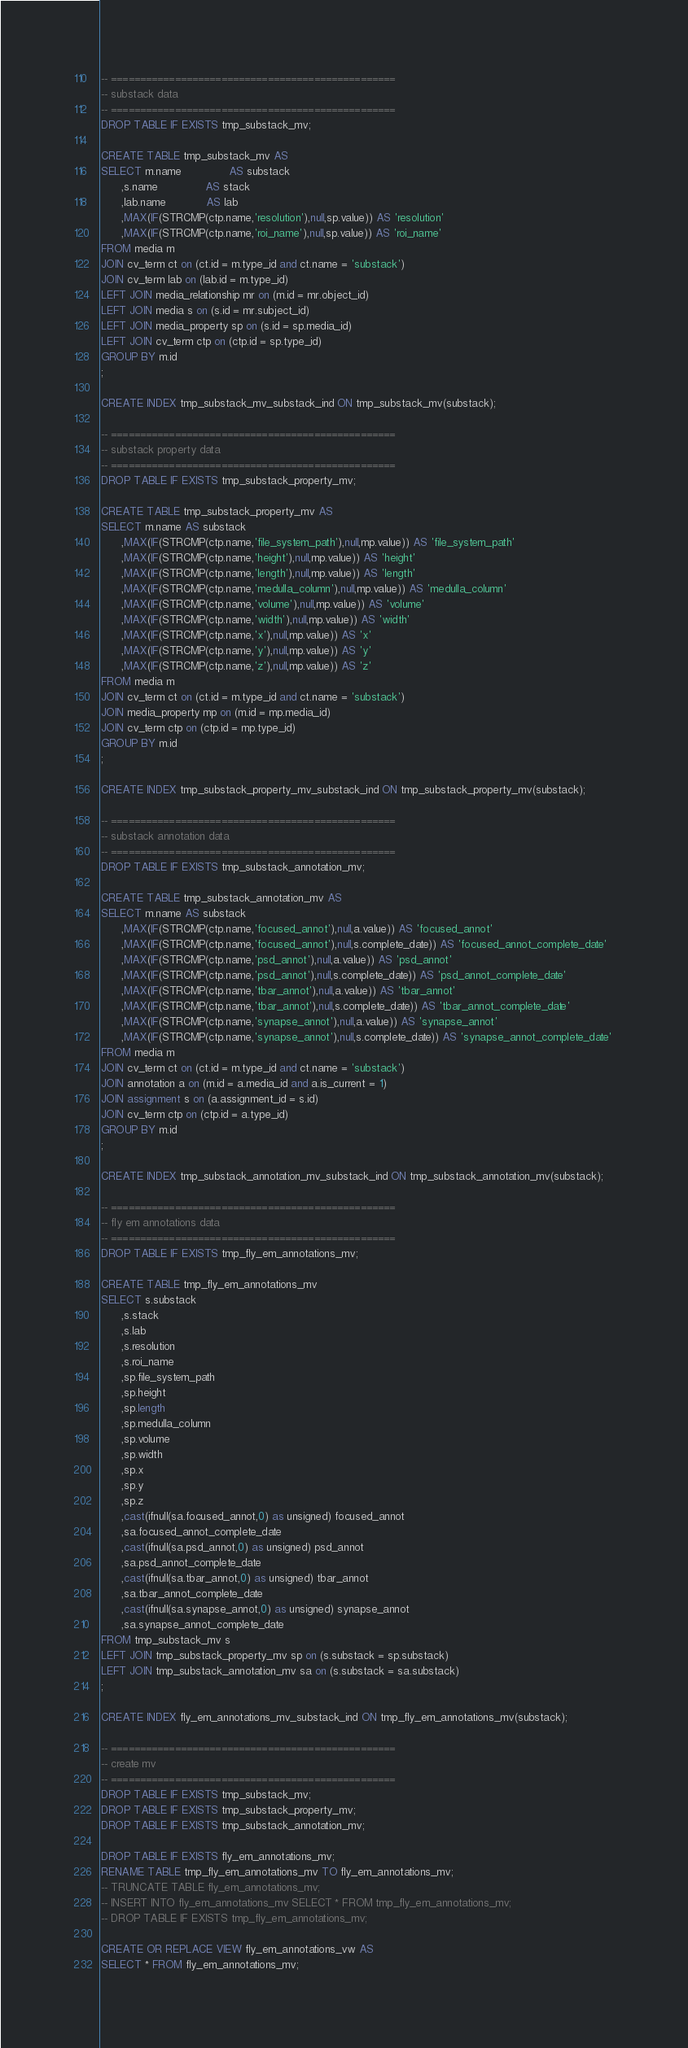Convert code to text. <code><loc_0><loc_0><loc_500><loc_500><_SQL_>-- =================================================
-- substack data
-- =================================================
DROP TABLE IF EXISTS tmp_substack_mv;

CREATE TABLE tmp_substack_mv AS
SELECT m.name              AS substack
      ,s.name              AS stack
      ,lab.name            AS lab
      ,MAX(IF(STRCMP(ctp.name,'resolution'),null,sp.value)) AS 'resolution'
      ,MAX(IF(STRCMP(ctp.name,'roi_name'),null,sp.value)) AS 'roi_name'
FROM media m
JOIN cv_term ct on (ct.id = m.type_id and ct.name = 'substack')
JOIN cv_term lab on (lab.id = m.type_id)
LEFT JOIN media_relationship mr on (m.id = mr.object_id)
LEFT JOIN media s on (s.id = mr.subject_id)
LEFT JOIN media_property sp on (s.id = sp.media_id)
LEFT JOIN cv_term ctp on (ctp.id = sp.type_id)
GROUP BY m.id
;

CREATE INDEX tmp_substack_mv_substack_ind ON tmp_substack_mv(substack);

-- =================================================
-- substack property data
-- =================================================
DROP TABLE IF EXISTS tmp_substack_property_mv;

CREATE TABLE tmp_substack_property_mv AS
SELECT m.name AS substack
      ,MAX(IF(STRCMP(ctp.name,'file_system_path'),null,mp.value)) AS 'file_system_path'
      ,MAX(IF(STRCMP(ctp.name,'height'),null,mp.value)) AS 'height'
      ,MAX(IF(STRCMP(ctp.name,'length'),null,mp.value)) AS 'length'
      ,MAX(IF(STRCMP(ctp.name,'medulla_column'),null,mp.value)) AS 'medulla_column'
      ,MAX(IF(STRCMP(ctp.name,'volume'),null,mp.value)) AS 'volume'
      ,MAX(IF(STRCMP(ctp.name,'width'),null,mp.value)) AS 'width'
      ,MAX(IF(STRCMP(ctp.name,'x'),null,mp.value)) AS 'x'
      ,MAX(IF(STRCMP(ctp.name,'y'),null,mp.value)) AS 'y'
      ,MAX(IF(STRCMP(ctp.name,'z'),null,mp.value)) AS 'z'
FROM media m
JOIN cv_term ct on (ct.id = m.type_id and ct.name = 'substack')
JOIN media_property mp on (m.id = mp.media_id)
JOIN cv_term ctp on (ctp.id = mp.type_id)
GROUP BY m.id
;

CREATE INDEX tmp_substack_property_mv_substack_ind ON tmp_substack_property_mv(substack);

-- =================================================
-- substack annotation data
-- =================================================
DROP TABLE IF EXISTS tmp_substack_annotation_mv;

CREATE TABLE tmp_substack_annotation_mv AS
SELECT m.name AS substack
      ,MAX(IF(STRCMP(ctp.name,'focused_annot'),null,a.value)) AS 'focused_annot'
      ,MAX(IF(STRCMP(ctp.name,'focused_annot'),null,s.complete_date)) AS 'focused_annot_complete_date' 
      ,MAX(IF(STRCMP(ctp.name,'psd_annot'),null,a.value)) AS 'psd_annot'
      ,MAX(IF(STRCMP(ctp.name,'psd_annot'),null,s.complete_date)) AS 'psd_annot_complete_date' 
      ,MAX(IF(STRCMP(ctp.name,'tbar_annot'),null,a.value)) AS 'tbar_annot'
      ,MAX(IF(STRCMP(ctp.name,'tbar_annot'),null,s.complete_date)) AS 'tbar_annot_complete_date' 
      ,MAX(IF(STRCMP(ctp.name,'synapse_annot'),null,a.value)) AS 'synapse_annot'
      ,MAX(IF(STRCMP(ctp.name,'synapse_annot'),null,s.complete_date)) AS 'synapse_annot_complete_date' 
FROM media m
JOIN cv_term ct on (ct.id = m.type_id and ct.name = 'substack')
JOIN annotation a on (m.id = a.media_id and a.is_current = 1)
JOIN assignment s on (a.assignment_id = s.id)
JOIN cv_term ctp on (ctp.id = a.type_id)
GROUP BY m.id
;

CREATE INDEX tmp_substack_annotation_mv_substack_ind ON tmp_substack_annotation_mv(substack);

-- =================================================
-- fly em annotations data
-- =================================================
DROP TABLE IF EXISTS tmp_fly_em_annotations_mv;

CREATE TABLE tmp_fly_em_annotations_mv
SELECT s.substack
      ,s.stack
      ,s.lab
      ,s.resolution
      ,s.roi_name
      ,sp.file_system_path
      ,sp.height
      ,sp.length
      ,sp.medulla_column
      ,sp.volume
      ,sp.width
      ,sp.x
      ,sp.y
      ,sp.z
      ,cast(ifnull(sa.focused_annot,0) as unsigned) focused_annot
      ,sa.focused_annot_complete_date
      ,cast(ifnull(sa.psd_annot,0) as unsigned) psd_annot
      ,sa.psd_annot_complete_date
      ,cast(ifnull(sa.tbar_annot,0) as unsigned) tbar_annot
      ,sa.tbar_annot_complete_date
      ,cast(ifnull(sa.synapse_annot,0) as unsigned) synapse_annot
      ,sa.synapse_annot_complete_date
FROM tmp_substack_mv s
LEFT JOIN tmp_substack_property_mv sp on (s.substack = sp.substack)
LEFT JOIN tmp_substack_annotation_mv sa on (s.substack = sa.substack)
;

CREATE INDEX fly_em_annotations_mv_substack_ind ON tmp_fly_em_annotations_mv(substack);

-- =================================================
-- create mv
-- =================================================
DROP TABLE IF EXISTS tmp_substack_mv;
DROP TABLE IF EXISTS tmp_substack_property_mv;
DROP TABLE IF EXISTS tmp_substack_annotation_mv;

DROP TABLE IF EXISTS fly_em_annotations_mv;
RENAME TABLE tmp_fly_em_annotations_mv TO fly_em_annotations_mv;
-- TRUNCATE TABLE fly_em_annotations_mv;
-- INSERT INTO fly_em_annotations_mv SELECT * FROM tmp_fly_em_annotations_mv;
-- DROP TABLE IF EXISTS tmp_fly_em_annotations_mv;

CREATE OR REPLACE VIEW fly_em_annotations_vw AS
SELECT * FROM fly_em_annotations_mv;

</code> 